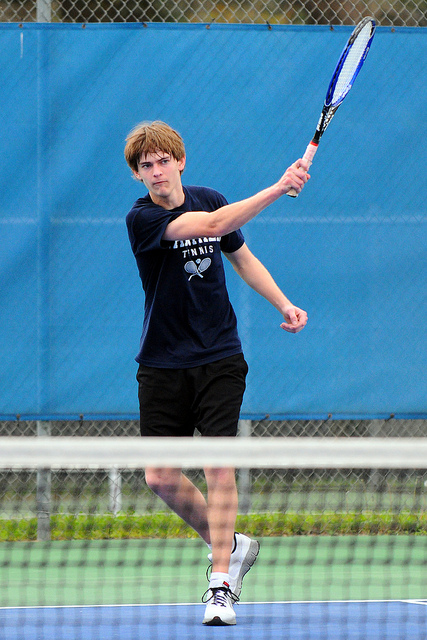<image>What college does the man play tennis for? I'm not sure what college the man plays tennis for. Possible options are 'uconn', 'harvard', 'princeton', 'unc', 'state', 'hunter college'. What college does the man play tennis for? I don't know what college the man plays tennis for. It can be UConn, Harvard, Princeton, UNC, or Hunter College. 